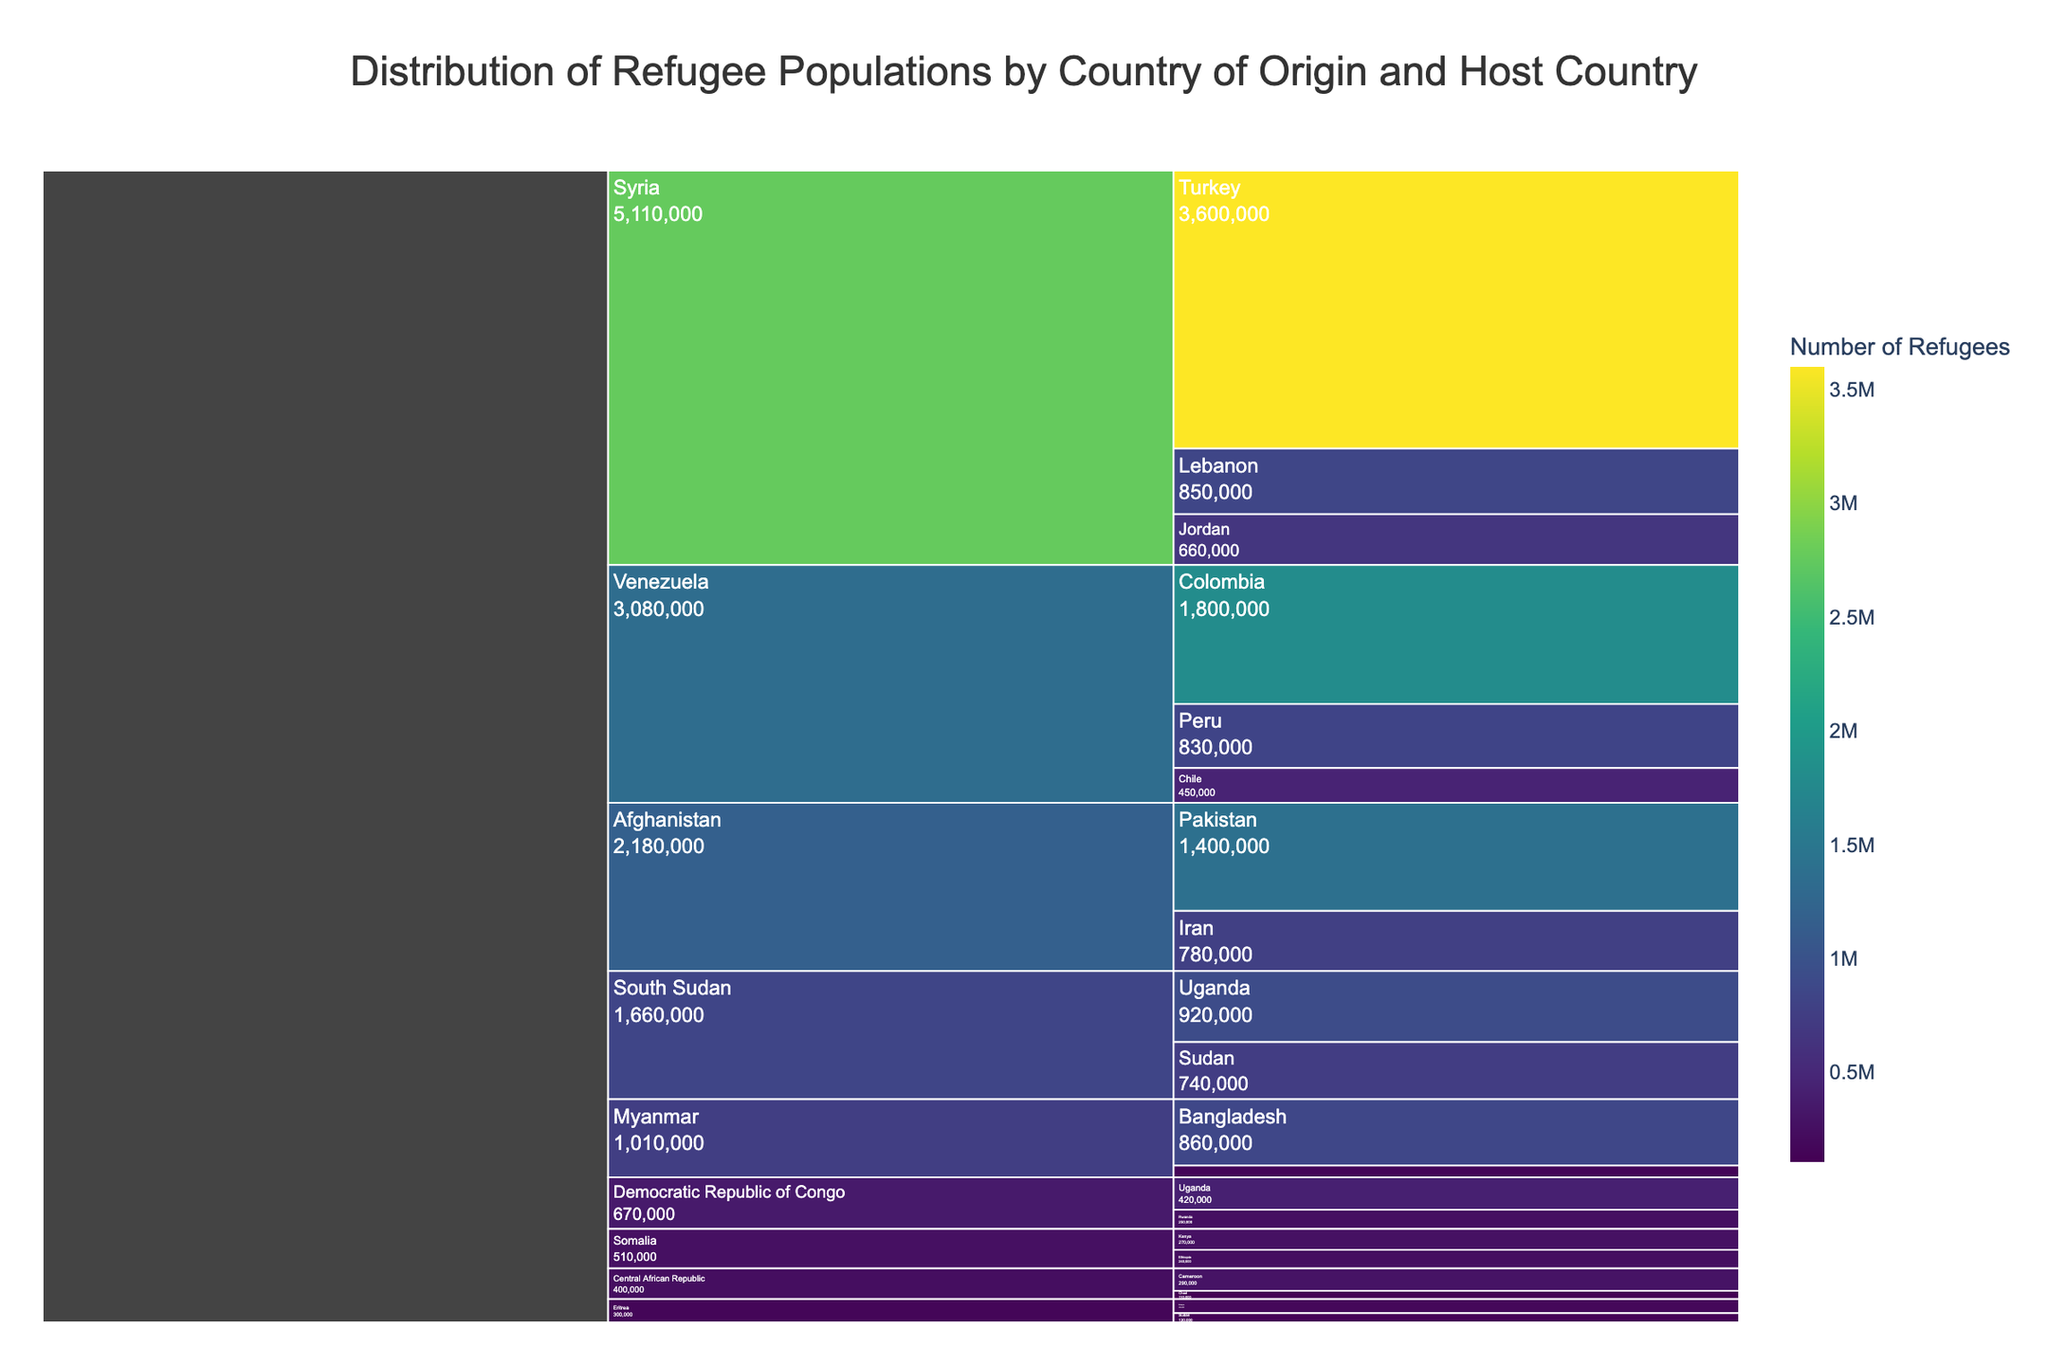How many host countries are there in total? Count the unique host countries listed under each country of origin.
Answer: 15 Which country of origin has the highest number of refugees hosted by Turkey? Find the largest value associated with Turkey and compare it to the values associated with Turkey for different countries of origin.
Answer: Syria How many refugees are there from Afghanistan in total? Sum the number of Afghan refugees in Pakistan and Iran: 1,400,000 (Pakistan) + 780,000 (Iran) = 2,180,000
Answer: 2,180,000 Which host country has the smallest number of refugees from Eritrea? Compare the refugee numbers hosted by Ethiopia and Sudan originating from Eritrea (180,000 in Ethiopia and 120,000 in Sudan).
Answer: Sudan What is the total number of refugees from Syria? Sum the number of Syrian refugees hosted by Turkey, Lebanon, and Jordan: 3,600,000 (Turkey) + 850,000 (Lebanon) + 660,000 (Jordan) = 5,110,000
Answer: 5,110,000 Which host country has a higher number of refugees from Venezuela: Peru or Chile? Compare the refugee numbers in Peru and Chile originating from Venezuela (830,000 in Peru and 450,000 in Chile).
Answer: Peru How many more refugees from Myanmar are in Bangladesh compared to Malaysia? Subtract the number of Myanmar refugees in Malaysia from those in Bangladesh: 860,000 (Bangladesh) - 150,000 (Malaysia) = 710,000
Answer: 710,000 Across all source countries, which host country has the largest refugee population? Identify the largest number associated with any host country in the chart.
Answer: Turkey Which countries of origin have refugees hosted by Uganda? Look under Uganda in the chart and list the corresponding countries of origin (South Sudan and Democratic Republic of Congo).
Answer: South Sudan and Democratic Republic of Congo What is the total number of refugees hosted by Sudan, from all origins? Sum the number of refugees from South Sudan and Eritrea hosted by Sudan: 740,000 (South Sudan) + 120,000 (Eritrea) = 860,000
Answer: 860,000 